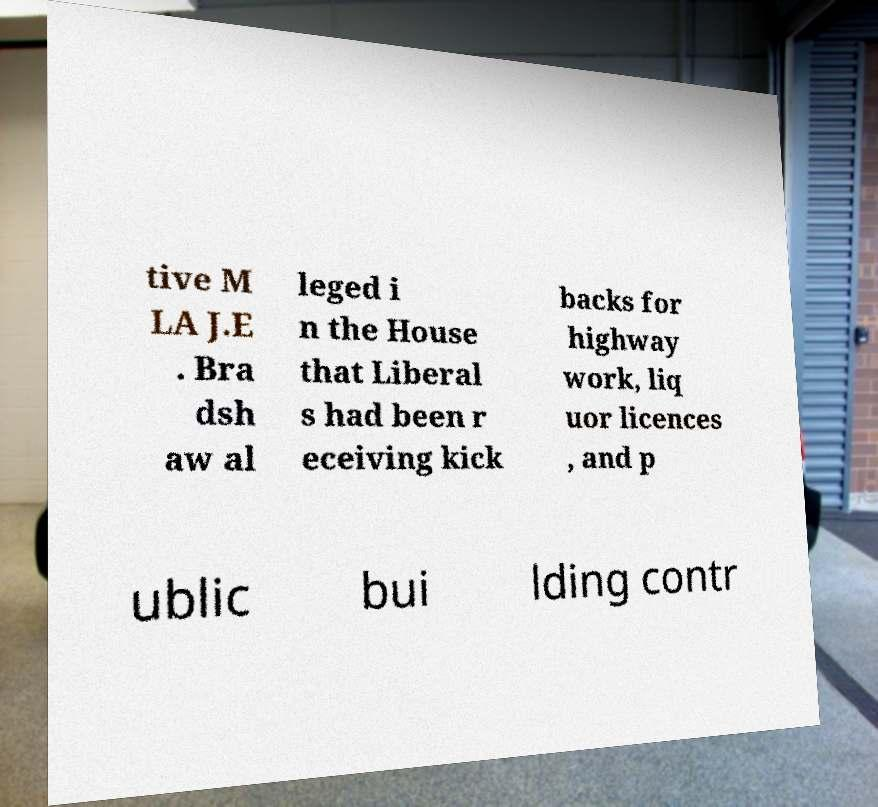Can you read and provide the text displayed in the image?This photo seems to have some interesting text. Can you extract and type it out for me? tive M LA J.E . Bra dsh aw al leged i n the House that Liberal s had been r eceiving kick backs for highway work, liq uor licences , and p ublic bui lding contr 